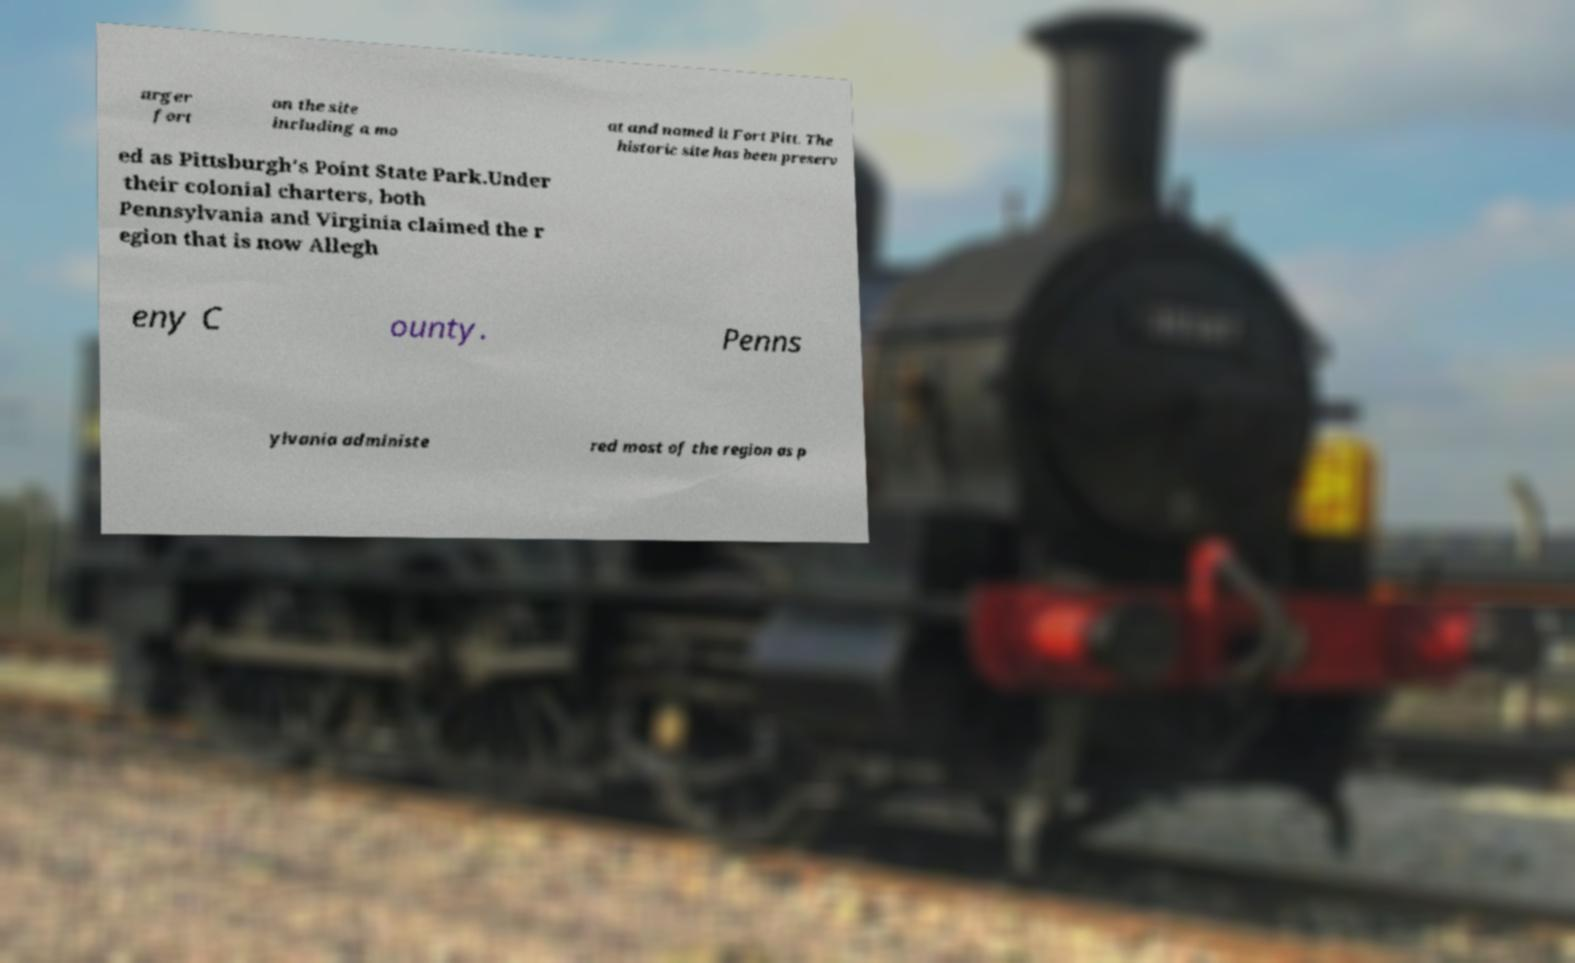Can you read and provide the text displayed in the image?This photo seems to have some interesting text. Can you extract and type it out for me? arger fort on the site including a mo at and named it Fort Pitt. The historic site has been preserv ed as Pittsburgh's Point State Park.Under their colonial charters, both Pennsylvania and Virginia claimed the r egion that is now Allegh eny C ounty. Penns ylvania administe red most of the region as p 